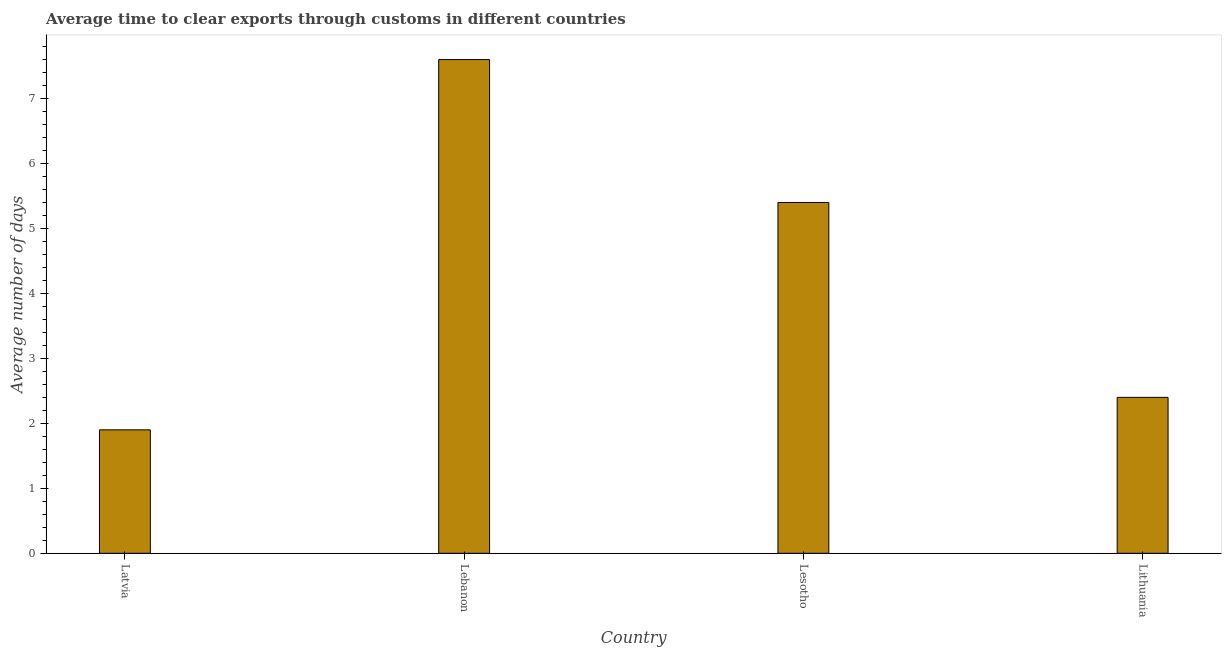Does the graph contain any zero values?
Your answer should be compact. No. Does the graph contain grids?
Keep it short and to the point. No. What is the title of the graph?
Keep it short and to the point. Average time to clear exports through customs in different countries. What is the label or title of the Y-axis?
Provide a short and direct response. Average number of days. What is the time to clear exports through customs in Latvia?
Provide a succinct answer. 1.9. In which country was the time to clear exports through customs maximum?
Ensure brevity in your answer.  Lebanon. In which country was the time to clear exports through customs minimum?
Your answer should be compact. Latvia. What is the sum of the time to clear exports through customs?
Keep it short and to the point. 17.3. What is the difference between the time to clear exports through customs in Latvia and Lebanon?
Ensure brevity in your answer.  -5.7. What is the average time to clear exports through customs per country?
Offer a terse response. 4.33. What is the median time to clear exports through customs?
Give a very brief answer. 3.9. What is the ratio of the time to clear exports through customs in Latvia to that in Lithuania?
Make the answer very short. 0.79. What is the difference between the highest and the second highest time to clear exports through customs?
Your answer should be compact. 2.2. Is the sum of the time to clear exports through customs in Lebanon and Lithuania greater than the maximum time to clear exports through customs across all countries?
Make the answer very short. Yes. What is the difference between the highest and the lowest time to clear exports through customs?
Provide a short and direct response. 5.7. In how many countries, is the time to clear exports through customs greater than the average time to clear exports through customs taken over all countries?
Your answer should be very brief. 2. What is the difference between two consecutive major ticks on the Y-axis?
Your answer should be very brief. 1. Are the values on the major ticks of Y-axis written in scientific E-notation?
Your answer should be very brief. No. What is the Average number of days in Latvia?
Provide a succinct answer. 1.9. What is the Average number of days of Lebanon?
Provide a short and direct response. 7.6. What is the Average number of days of Lithuania?
Provide a succinct answer. 2.4. What is the difference between the Average number of days in Latvia and Lebanon?
Provide a succinct answer. -5.7. What is the difference between the Average number of days in Latvia and Lithuania?
Make the answer very short. -0.5. What is the difference between the Average number of days in Lebanon and Lesotho?
Your answer should be compact. 2.2. What is the ratio of the Average number of days in Latvia to that in Lesotho?
Provide a short and direct response. 0.35. What is the ratio of the Average number of days in Latvia to that in Lithuania?
Your answer should be very brief. 0.79. What is the ratio of the Average number of days in Lebanon to that in Lesotho?
Ensure brevity in your answer.  1.41. What is the ratio of the Average number of days in Lebanon to that in Lithuania?
Ensure brevity in your answer.  3.17. What is the ratio of the Average number of days in Lesotho to that in Lithuania?
Provide a succinct answer. 2.25. 